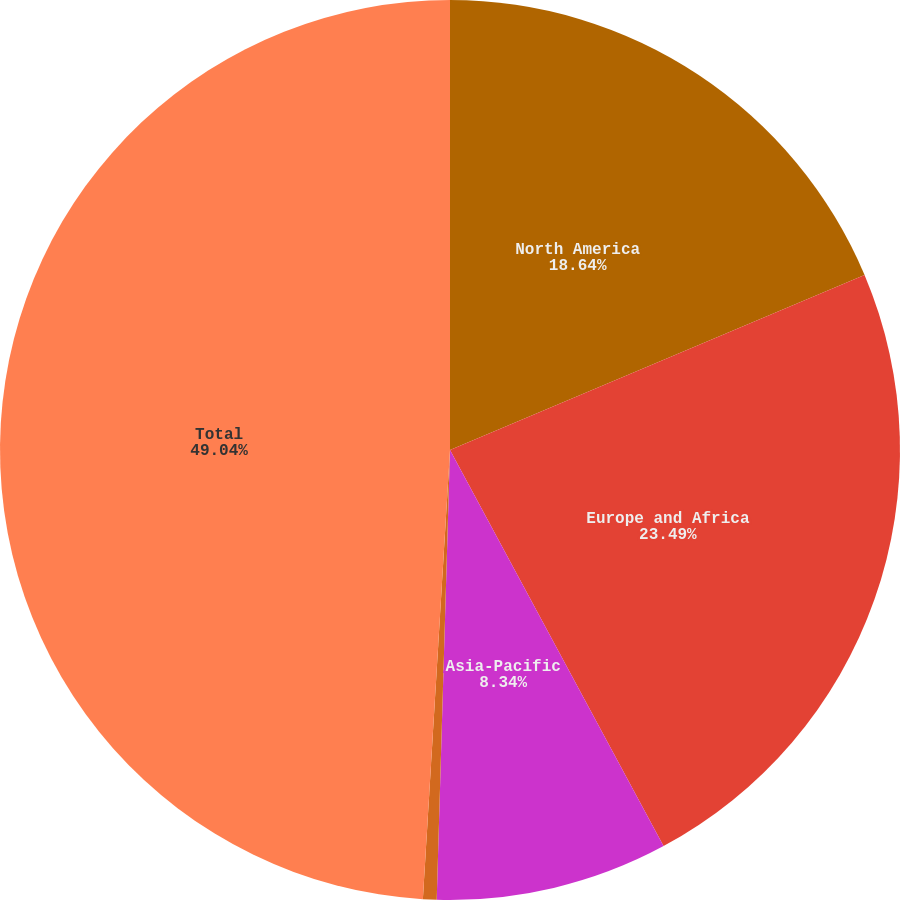Convert chart. <chart><loc_0><loc_0><loc_500><loc_500><pie_chart><fcel>North America<fcel>Europe and Africa<fcel>Asia-Pacific<fcel>South America<fcel>Total<nl><fcel>18.64%<fcel>23.49%<fcel>8.34%<fcel>0.49%<fcel>49.04%<nl></chart> 